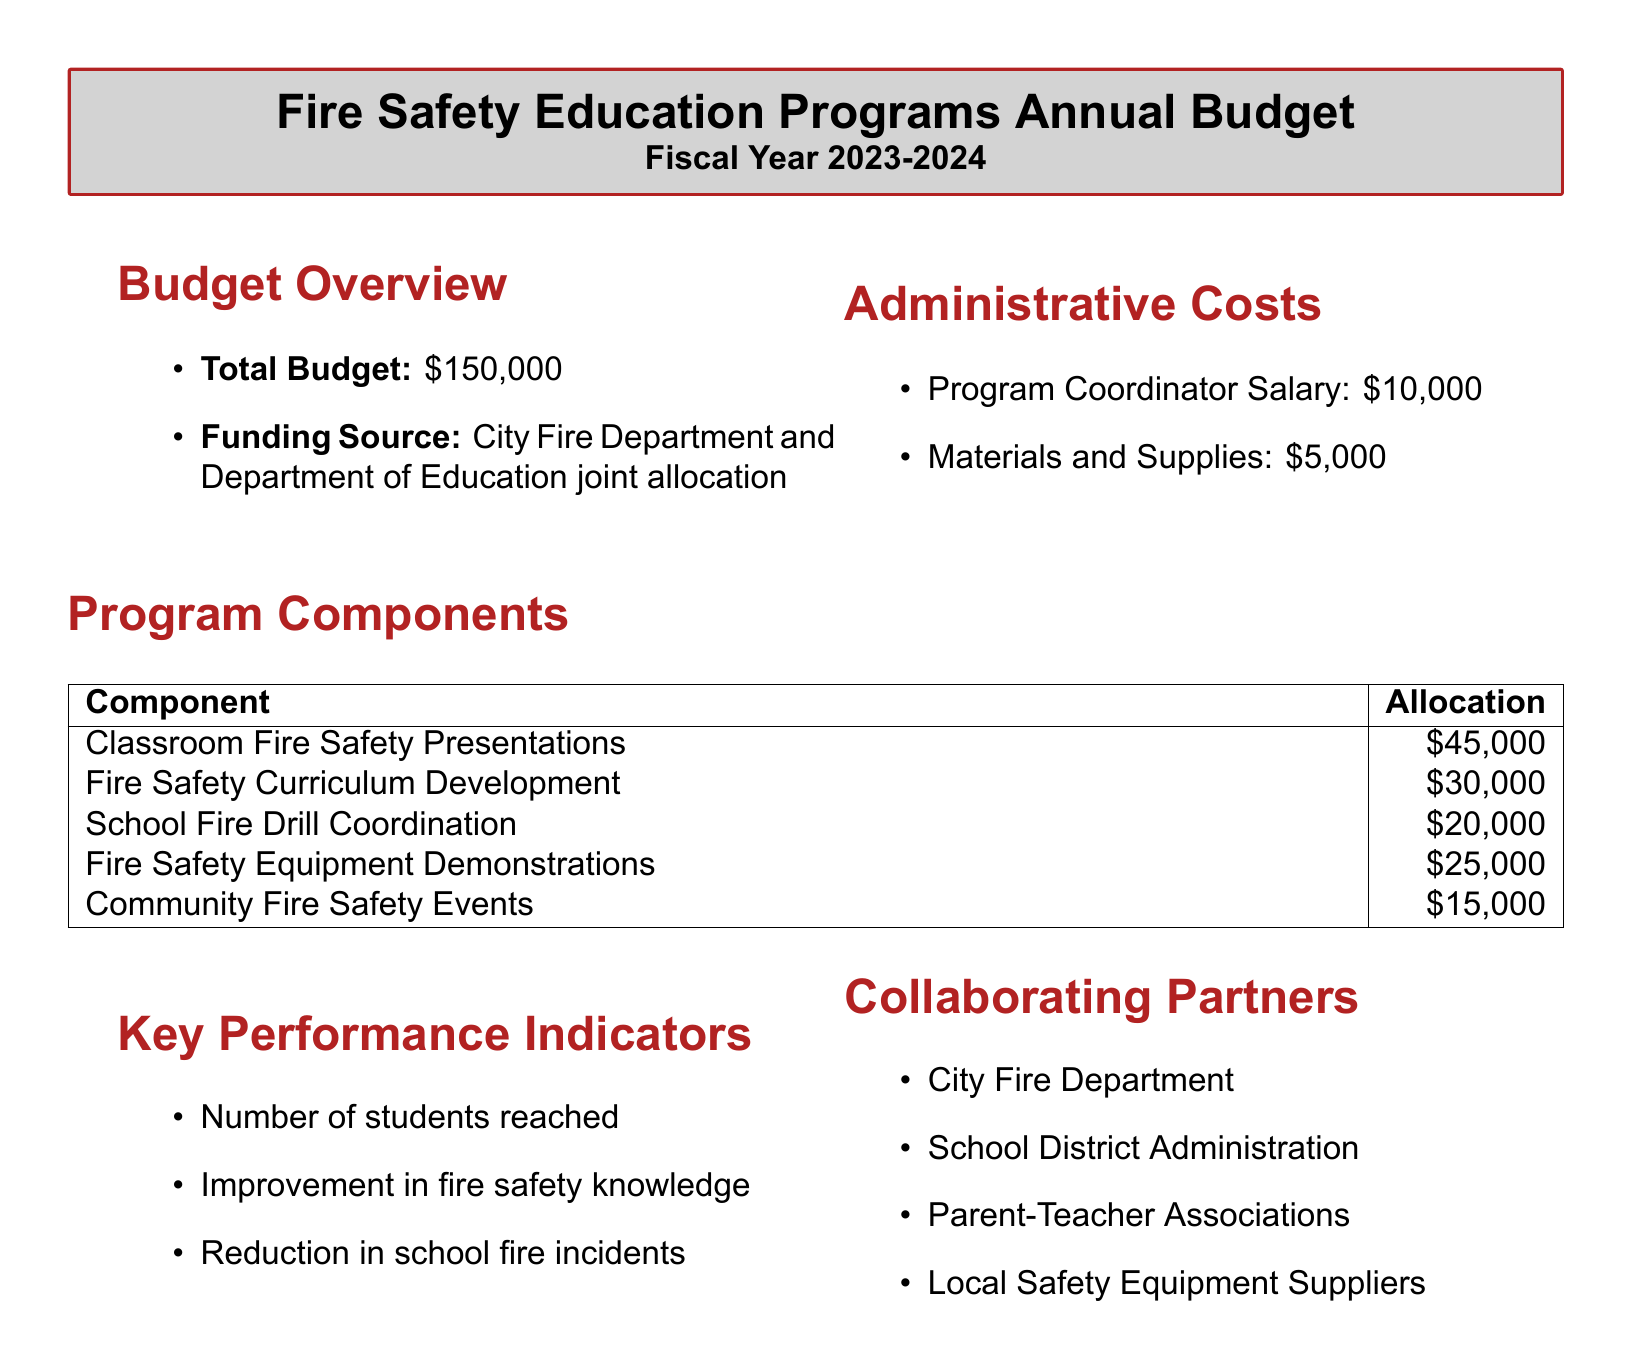What is the total budget for fire safety education programs? The total budget is stated explicitly in the document as $150,000.
Answer: $150,000 Who are the collaborating partners listed in the document? The document lists multiple collaborators, including the City Fire Department, School District Administration, Parent-Teacher Associations, and Local Safety Equipment Suppliers.
Answer: City Fire Department, School District Administration, Parent-Teacher Associations, Local Safety Equipment Suppliers What is allocated for Classroom Fire Safety Presentations? The document specifies that $45,000 is allocated for Classroom Fire Safety Presentations.
Answer: $45,000 What is the funding source for the budget? The funding source is explained in the document. It mentions a joint allocation from the City Fire Department and the Department of Education.
Answer: City Fire Department and Department of Education joint allocation How much is allocated for Community Fire Safety Events? The document indicates that $15,000 is allocated specifically for Community Fire Safety Events.
Answer: $15,000 What is the salary for the Program Coordinator? The document states that the Program Coordinator's salary is $10,000.
Answer: $10,000 What is one of the key performance indicators? The document mentions various performance indicators, one of which is the number of students reached.
Answer: Number of students reached Which item has the highest funding allocation? The document shows that Classroom Fire Safety Presentations have the highest allocation of $45,000.
Answer: Classroom Fire Safety Presentations How much funding is allocated for Fire Safety Curriculum Development? The document specifies that $30,000 is allocated for Fire Safety Curriculum Development.
Answer: $30,000 